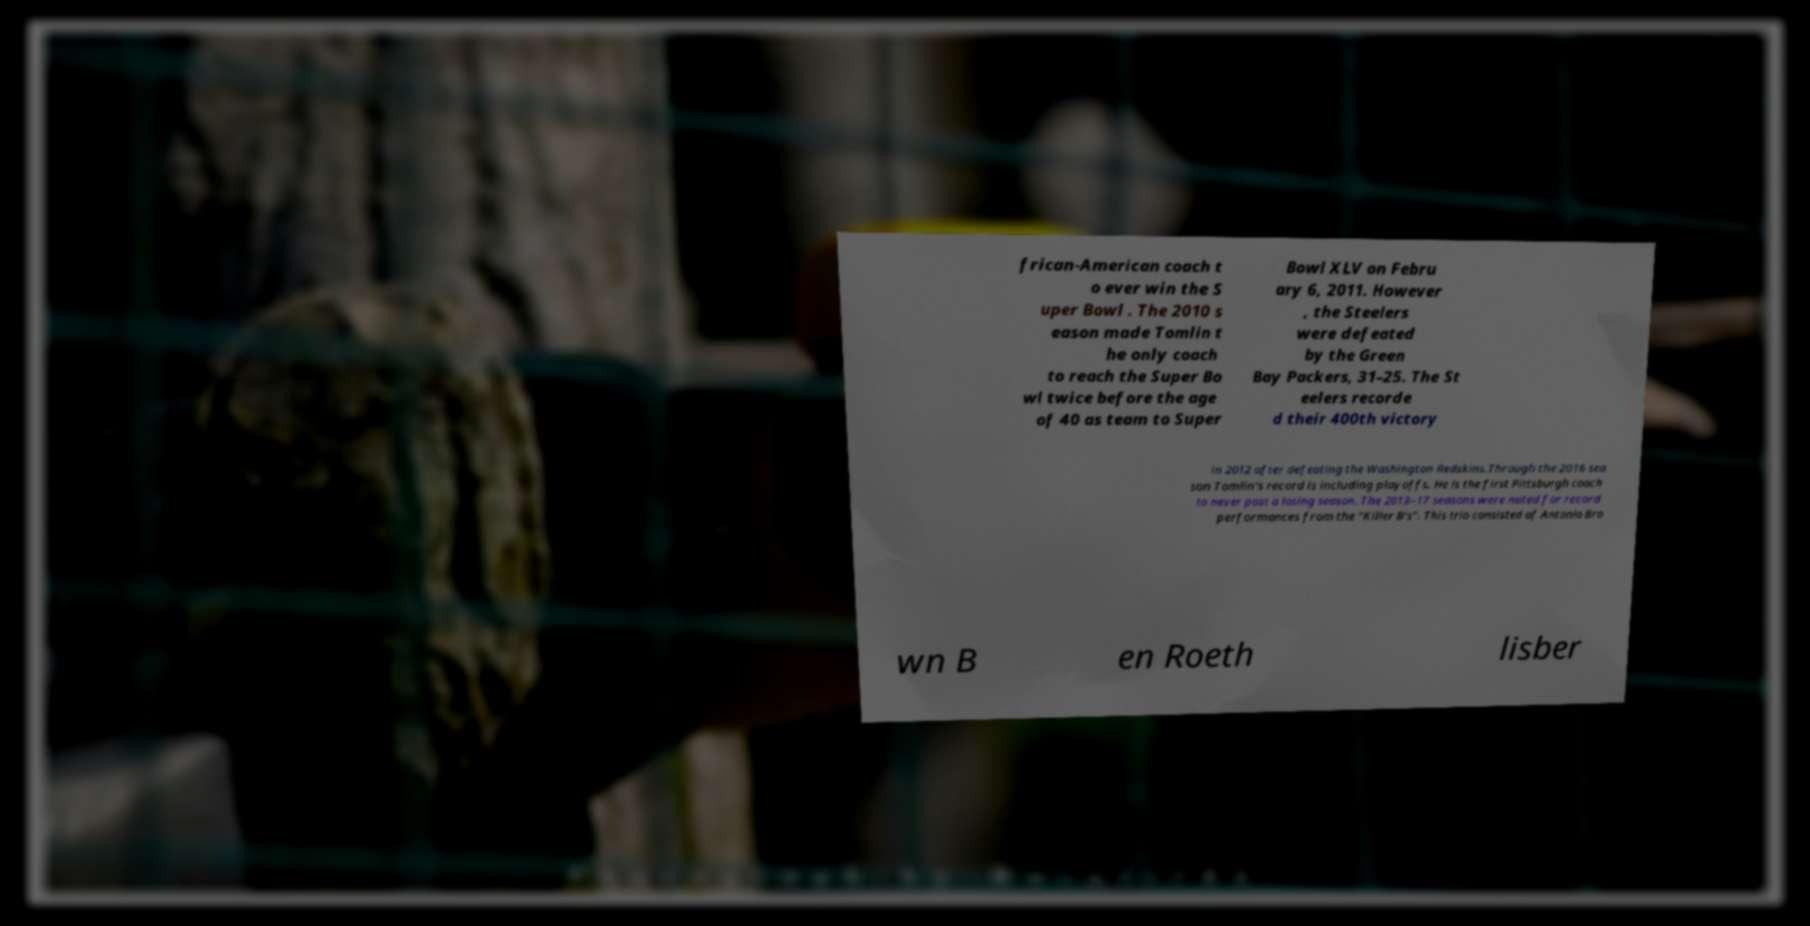Can you accurately transcribe the text from the provided image for me? frican-American coach t o ever win the S uper Bowl . The 2010 s eason made Tomlin t he only coach to reach the Super Bo wl twice before the age of 40 as team to Super Bowl XLV on Febru ary 6, 2011. However , the Steelers were defeated by the Green Bay Packers, 31–25. The St eelers recorde d their 400th victory in 2012 after defeating the Washington Redskins.Through the 2016 sea son Tomlin's record is including playoffs. He is the first Pittsburgh coach to never post a losing season. The 2013–17 seasons were noted for record performances from the "Killer B's". This trio consisted of Antonio Bro wn B en Roeth lisber 